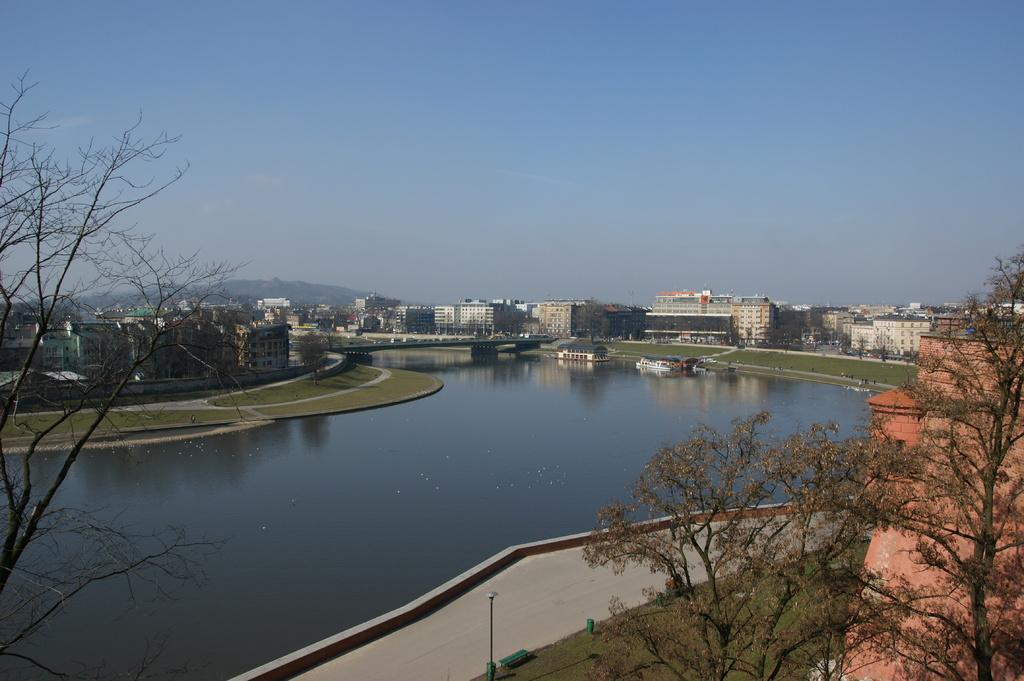What type of structures can be seen in the image? There are buildings in the image. What natural elements are present in the image? There are trees and water visible in the image. What objects can be seen floating on the water? There are boats in the image. What can be seen in the background of the image? The sky, mountains, poles, and grass are visible in the background of the image. What type of fruit is hanging from the poles in the background of the image? There is no fruit hanging from the poles in the background of the image. What is the zinc content of the water visible in the image? There is no information provided about the zinc content of the water in the image. 